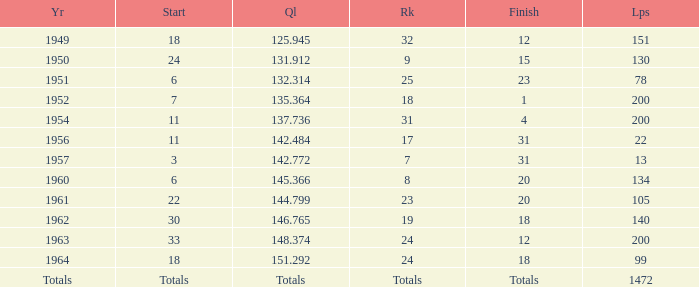Name the rank for 151 Laps 32.0. 